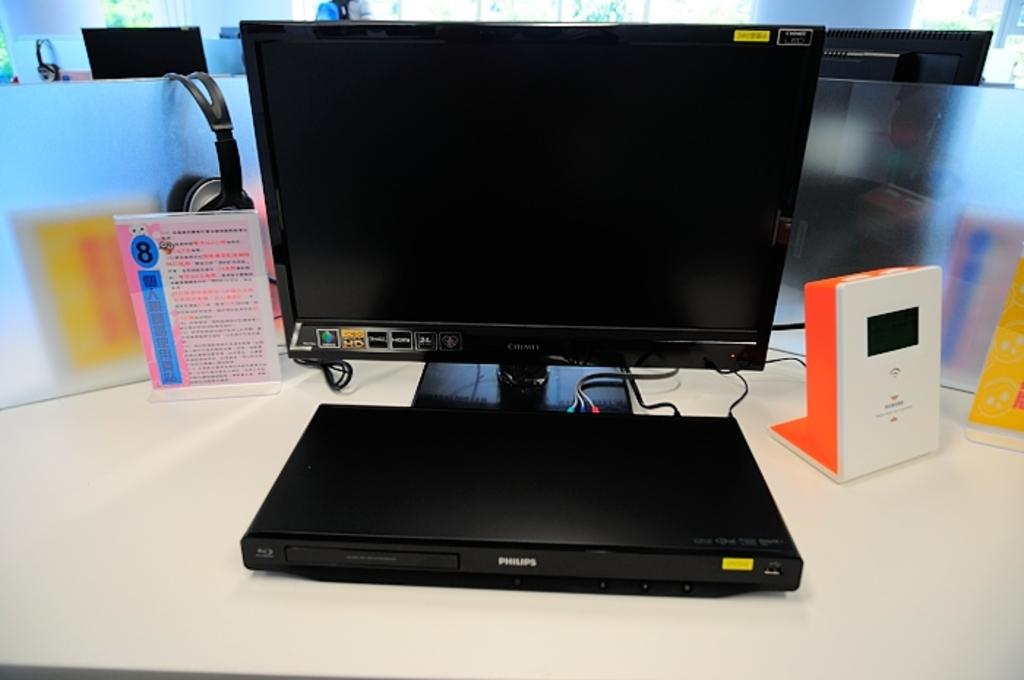<image>
Relay a brief, clear account of the picture shown. A computer monitor is hooked up to a Philips DVD player. 